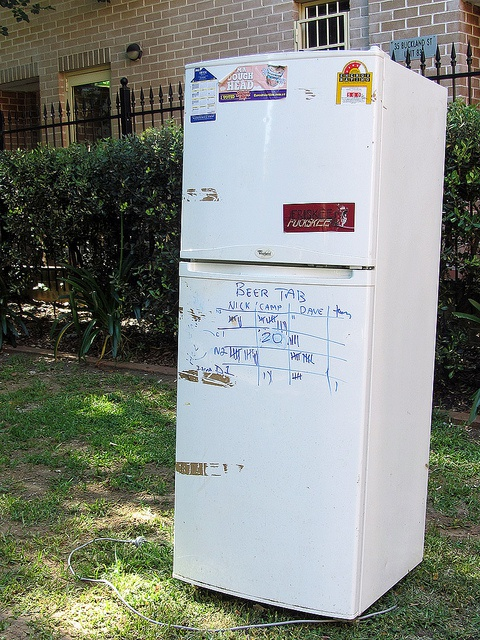Describe the objects in this image and their specific colors. I can see a refrigerator in black, lightgray, lightblue, and darkgray tones in this image. 